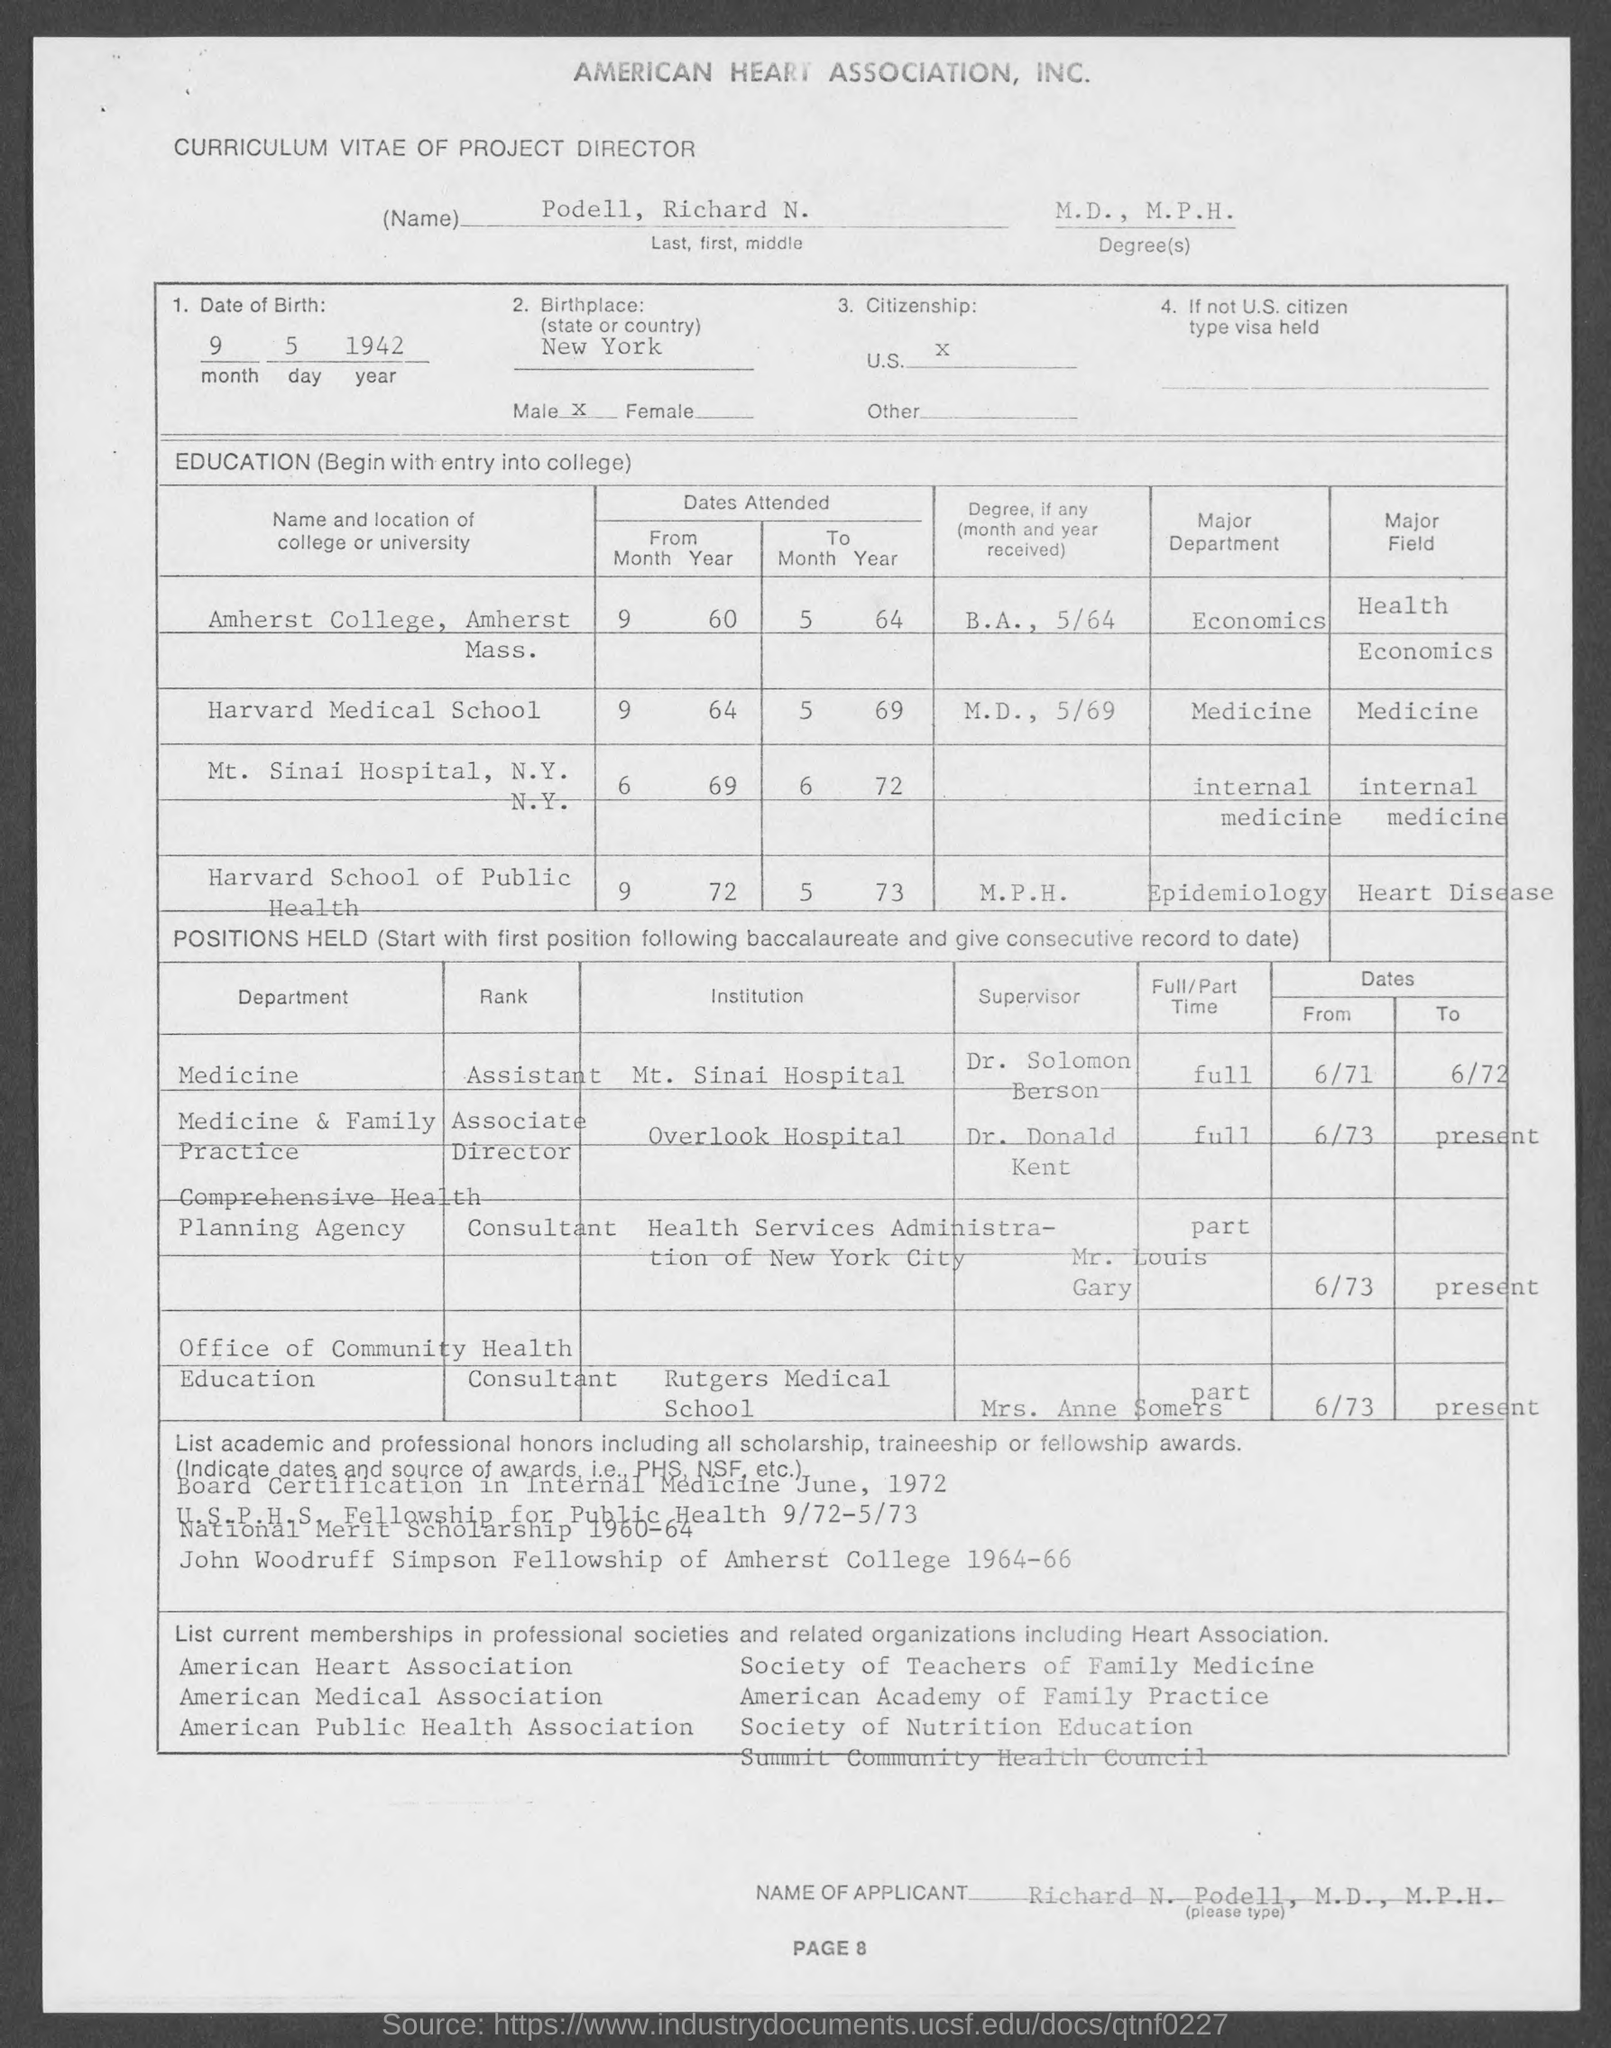What is the name mentioned in the curriculum vitae ?
Offer a very short reply. Podell, Richard N. What is the degree mentioned in the page ?
Provide a succinct answer. M.D. , M.P.H. What is the date of birth mentioned in the given curriculum vitae ?
Ensure brevity in your answer.  9 5 1942. What is the name of the birth place mentioned in the given curriculum vitae ?
Ensure brevity in your answer.  New york. What is the citizenship mentioned in the given curriculum vitae ?
Your answer should be compact. U.S. What is the name of the applicant mentioned in the given curriculum vitae ?
Keep it short and to the point. RICHARD N. PODELL. 